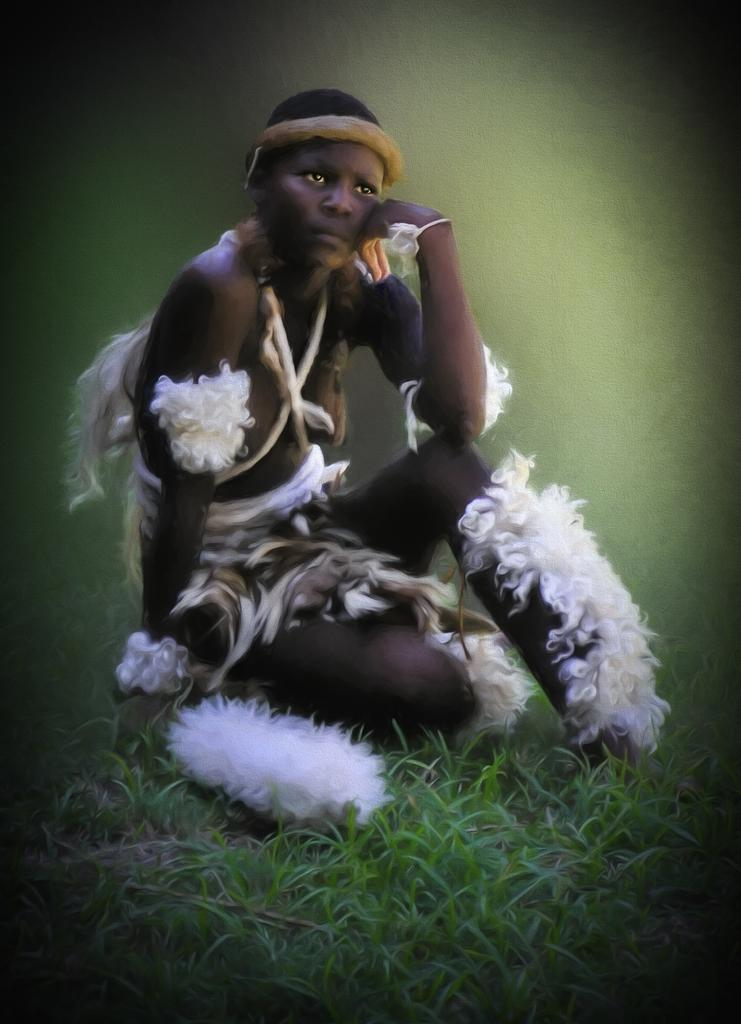What is the woman in the image doing? The woman is sitting on the grass in the image. What can be seen on the ground near the woman? Feathers are present in the image. How would you describe the background of the image? The background is blurred and green. What type of bone can be seen in the woman's hand in the image? There is no bone present in the woman's hand or anywhere else in the image. 